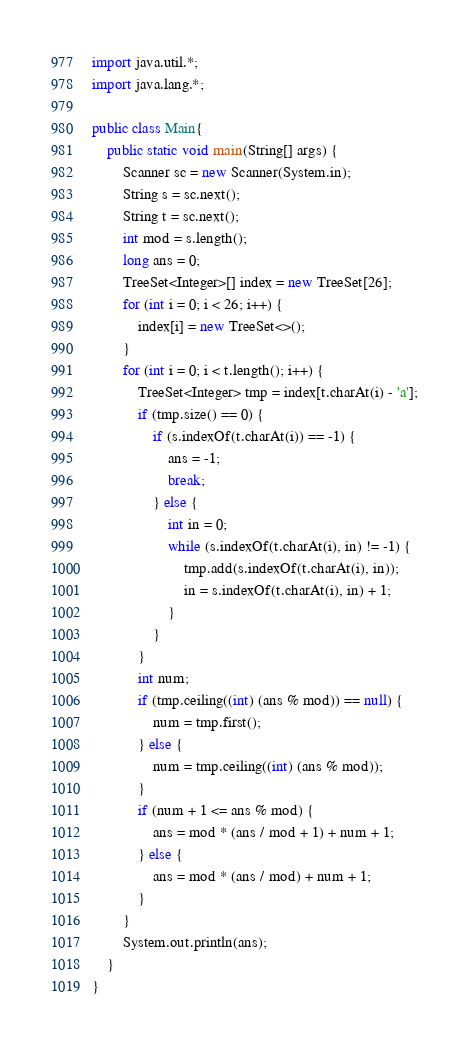<code> <loc_0><loc_0><loc_500><loc_500><_Java_>import java.util.*;
import java.lang.*;

public class Main{
	public static void main(String[] args) {
		Scanner sc = new Scanner(System.in);
		String s = sc.next();
		String t = sc.next();
		int mod = s.length();
		long ans = 0;
		TreeSet<Integer>[] index = new TreeSet[26];
		for (int i = 0; i < 26; i++) {
			index[i] = new TreeSet<>();
		}
		for (int i = 0; i < t.length(); i++) {
			TreeSet<Integer> tmp = index[t.charAt(i) - 'a'];
			if (tmp.size() == 0) {
				if (s.indexOf(t.charAt(i)) == -1) {
					ans = -1;
					break;
				} else {
					int in = 0;
					while (s.indexOf(t.charAt(i), in) != -1) {
						tmp.add(s.indexOf(t.charAt(i), in));
						in = s.indexOf(t.charAt(i), in) + 1;
					}
				}
			}
			int num;
			if (tmp.ceiling((int) (ans % mod)) == null) {
				num = tmp.first();
			} else {
				num = tmp.ceiling((int) (ans % mod));
			}
			if (num + 1 <= ans % mod) {
				ans = mod * (ans / mod + 1) + num + 1;
			} else {
				ans = mod * (ans / mod) + num + 1;
			}
		}
		System.out.println(ans);
	}
}
</code> 